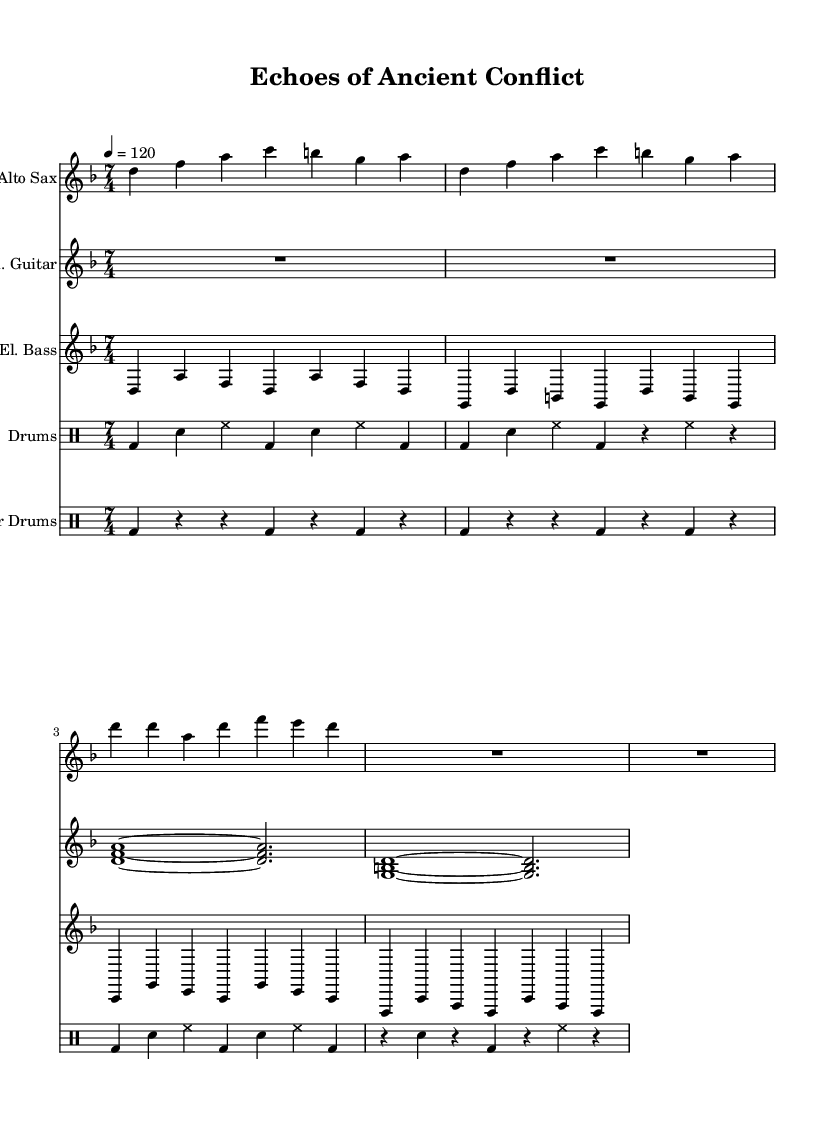What is the key signature of this music? The key signature, indicated before the notes, shows two flats (B flat and E flat), which corresponds to the key of D minor.
Answer: D minor What is the time signature of this music? The time signature is indicated at the beginning of the staff and shows 7 over 4, meaning there are seven beats in each measure and the quarter note gets one beat.
Answer: 7/4 What is the tempo marking for this piece? The tempo marking is found above the music and states a speed of 120 beats per minute, indicating a moderate pace for the performance.
Answer: 120 How many measures are there in the saxophone part? By counting the groupings of notes and rests in the saxophone staff, there are a total of four measures visible.
Answer: 4 Which instrument plays rhythmic patterns typical of traditional war music? The sheet music has a specific part labeled "War Drums," which features a distinct rhythmic pattern typical of percussion styles used in various cultures' battle scenes.
Answer: War Drums What is the rhythmic pattern used in the bass part? The bass part consists of quarter notes played in a repetitive sequence, characterized by a consistent rhythmic structure across the measures.
Answer: Quarter notes How does the role of the drums differ from the war drums in this piece? The standard drum part includes a mix of snare, bass, and hi-hat sounds, creating an overall groove, while the war drums focus on simple, strong beats emphasizing the warrior aspect of the music.
Answer: Drums vs. War Drums 